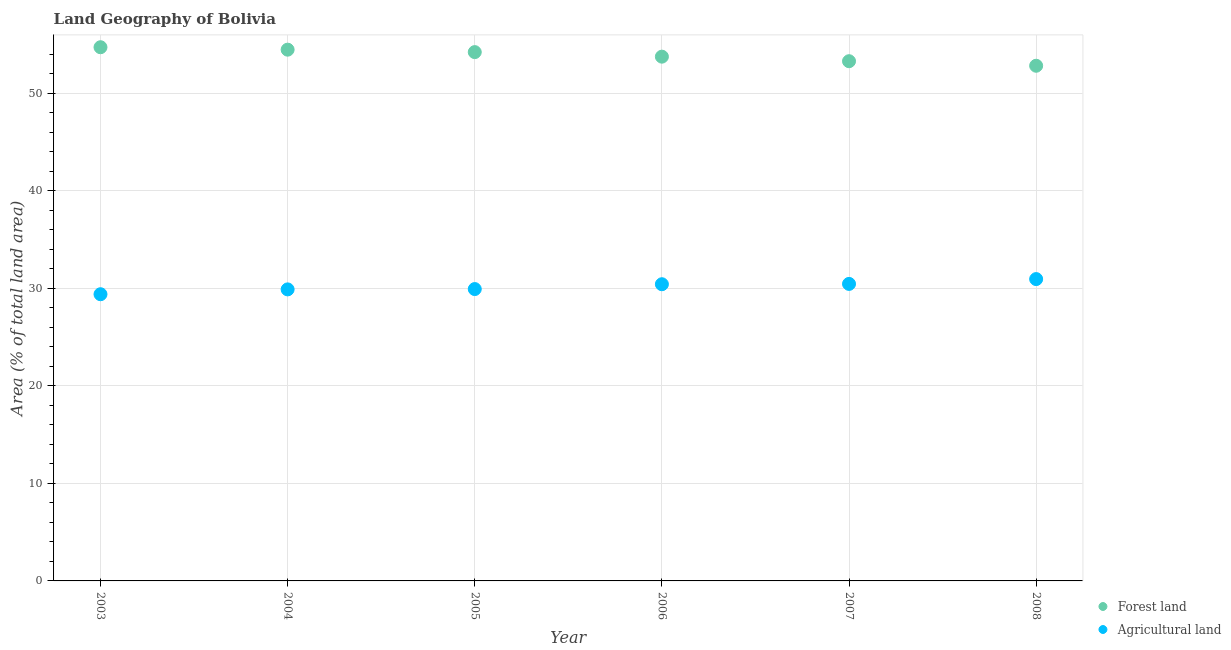What is the percentage of land area under agriculture in 2003?
Keep it short and to the point. 29.39. Across all years, what is the maximum percentage of land area under agriculture?
Your response must be concise. 30.95. Across all years, what is the minimum percentage of land area under agriculture?
Provide a succinct answer. 29.39. What is the total percentage of land area under agriculture in the graph?
Provide a short and direct response. 181.03. What is the difference between the percentage of land area under agriculture in 2003 and that in 2005?
Your answer should be very brief. -0.53. What is the difference between the percentage of land area under agriculture in 2007 and the percentage of land area under forests in 2006?
Provide a succinct answer. -23.3. What is the average percentage of land area under agriculture per year?
Offer a very short reply. 30.17. In the year 2007, what is the difference between the percentage of land area under agriculture and percentage of land area under forests?
Ensure brevity in your answer.  -22.83. What is the ratio of the percentage of land area under agriculture in 2005 to that in 2006?
Offer a terse response. 0.98. Is the difference between the percentage of land area under forests in 2004 and 2008 greater than the difference between the percentage of land area under agriculture in 2004 and 2008?
Your answer should be compact. Yes. What is the difference between the highest and the second highest percentage of land area under agriculture?
Keep it short and to the point. 0.49. What is the difference between the highest and the lowest percentage of land area under forests?
Offer a very short reply. 1.9. Is the sum of the percentage of land area under forests in 2003 and 2004 greater than the maximum percentage of land area under agriculture across all years?
Keep it short and to the point. Yes. Is the percentage of land area under agriculture strictly less than the percentage of land area under forests over the years?
Provide a short and direct response. Yes. How many dotlines are there?
Provide a succinct answer. 2. How many years are there in the graph?
Your answer should be very brief. 6. Does the graph contain grids?
Give a very brief answer. Yes. What is the title of the graph?
Ensure brevity in your answer.  Land Geography of Bolivia. What is the label or title of the Y-axis?
Your answer should be very brief. Area (% of total land area). What is the Area (% of total land area) in Forest land in 2003?
Provide a short and direct response. 54.72. What is the Area (% of total land area) of Agricultural land in 2003?
Keep it short and to the point. 29.39. What is the Area (% of total land area) in Forest land in 2004?
Your answer should be very brief. 54.47. What is the Area (% of total land area) of Agricultural land in 2004?
Make the answer very short. 29.89. What is the Area (% of total land area) in Forest land in 2005?
Your answer should be very brief. 54.22. What is the Area (% of total land area) in Agricultural land in 2005?
Provide a succinct answer. 29.92. What is the Area (% of total land area) of Forest land in 2006?
Provide a succinct answer. 53.75. What is the Area (% of total land area) in Agricultural land in 2006?
Give a very brief answer. 30.42. What is the Area (% of total land area) in Forest land in 2007?
Provide a short and direct response. 53.29. What is the Area (% of total land area) in Agricultural land in 2007?
Offer a very short reply. 30.45. What is the Area (% of total land area) in Forest land in 2008?
Make the answer very short. 52.82. What is the Area (% of total land area) of Agricultural land in 2008?
Your response must be concise. 30.95. Across all years, what is the maximum Area (% of total land area) of Forest land?
Your response must be concise. 54.72. Across all years, what is the maximum Area (% of total land area) in Agricultural land?
Make the answer very short. 30.95. Across all years, what is the minimum Area (% of total land area) of Forest land?
Offer a very short reply. 52.82. Across all years, what is the minimum Area (% of total land area) of Agricultural land?
Make the answer very short. 29.39. What is the total Area (% of total land area) in Forest land in the graph?
Ensure brevity in your answer.  323.26. What is the total Area (% of total land area) of Agricultural land in the graph?
Keep it short and to the point. 181.03. What is the difference between the Area (% of total land area) in Forest land in 2003 and that in 2004?
Your answer should be very brief. 0.25. What is the difference between the Area (% of total land area) in Agricultural land in 2003 and that in 2004?
Your answer should be compact. -0.5. What is the difference between the Area (% of total land area) in Forest land in 2003 and that in 2005?
Offer a very short reply. 0.5. What is the difference between the Area (% of total land area) in Agricultural land in 2003 and that in 2005?
Keep it short and to the point. -0.53. What is the difference between the Area (% of total land area) in Forest land in 2003 and that in 2006?
Your answer should be very brief. 0.97. What is the difference between the Area (% of total land area) in Agricultural land in 2003 and that in 2006?
Offer a terse response. -1.02. What is the difference between the Area (% of total land area) of Forest land in 2003 and that in 2007?
Provide a succinct answer. 1.43. What is the difference between the Area (% of total land area) in Agricultural land in 2003 and that in 2007?
Provide a short and direct response. -1.06. What is the difference between the Area (% of total land area) in Forest land in 2003 and that in 2008?
Provide a succinct answer. 1.9. What is the difference between the Area (% of total land area) in Agricultural land in 2003 and that in 2008?
Make the answer very short. -1.55. What is the difference between the Area (% of total land area) of Forest land in 2004 and that in 2005?
Ensure brevity in your answer.  0.25. What is the difference between the Area (% of total land area) of Agricultural land in 2004 and that in 2005?
Keep it short and to the point. -0.03. What is the difference between the Area (% of total land area) of Forest land in 2004 and that in 2006?
Offer a very short reply. 0.72. What is the difference between the Area (% of total land area) of Agricultural land in 2004 and that in 2006?
Provide a succinct answer. -0.53. What is the difference between the Area (% of total land area) in Forest land in 2004 and that in 2007?
Your response must be concise. 1.18. What is the difference between the Area (% of total land area) of Agricultural land in 2004 and that in 2007?
Offer a terse response. -0.56. What is the difference between the Area (% of total land area) in Forest land in 2004 and that in 2008?
Your answer should be compact. 1.65. What is the difference between the Area (% of total land area) in Agricultural land in 2004 and that in 2008?
Keep it short and to the point. -1.06. What is the difference between the Area (% of total land area) in Forest land in 2005 and that in 2006?
Give a very brief answer. 0.47. What is the difference between the Area (% of total land area) in Agricultural land in 2005 and that in 2006?
Ensure brevity in your answer.  -0.5. What is the difference between the Area (% of total land area) in Forest land in 2005 and that in 2007?
Offer a terse response. 0.93. What is the difference between the Area (% of total land area) of Agricultural land in 2005 and that in 2007?
Provide a succinct answer. -0.53. What is the difference between the Area (% of total land area) of Forest land in 2005 and that in 2008?
Offer a terse response. 1.4. What is the difference between the Area (% of total land area) in Agricultural land in 2005 and that in 2008?
Your answer should be compact. -1.02. What is the difference between the Area (% of total land area) of Forest land in 2006 and that in 2007?
Give a very brief answer. 0.47. What is the difference between the Area (% of total land area) of Agricultural land in 2006 and that in 2007?
Make the answer very short. -0.03. What is the difference between the Area (% of total land area) of Forest land in 2006 and that in 2008?
Make the answer very short. 0.93. What is the difference between the Area (% of total land area) in Agricultural land in 2006 and that in 2008?
Offer a terse response. -0.53. What is the difference between the Area (% of total land area) of Forest land in 2007 and that in 2008?
Offer a terse response. 0.47. What is the difference between the Area (% of total land area) of Agricultural land in 2007 and that in 2008?
Offer a very short reply. -0.49. What is the difference between the Area (% of total land area) in Forest land in 2003 and the Area (% of total land area) in Agricultural land in 2004?
Provide a short and direct response. 24.83. What is the difference between the Area (% of total land area) in Forest land in 2003 and the Area (% of total land area) in Agricultural land in 2005?
Offer a very short reply. 24.8. What is the difference between the Area (% of total land area) of Forest land in 2003 and the Area (% of total land area) of Agricultural land in 2006?
Give a very brief answer. 24.3. What is the difference between the Area (% of total land area) in Forest land in 2003 and the Area (% of total land area) in Agricultural land in 2007?
Provide a short and direct response. 24.27. What is the difference between the Area (% of total land area) in Forest land in 2003 and the Area (% of total land area) in Agricultural land in 2008?
Give a very brief answer. 23.77. What is the difference between the Area (% of total land area) of Forest land in 2004 and the Area (% of total land area) of Agricultural land in 2005?
Offer a terse response. 24.54. What is the difference between the Area (% of total land area) of Forest land in 2004 and the Area (% of total land area) of Agricultural land in 2006?
Provide a succinct answer. 24.05. What is the difference between the Area (% of total land area) of Forest land in 2004 and the Area (% of total land area) of Agricultural land in 2007?
Your answer should be compact. 24.02. What is the difference between the Area (% of total land area) of Forest land in 2004 and the Area (% of total land area) of Agricultural land in 2008?
Provide a short and direct response. 23.52. What is the difference between the Area (% of total land area) of Forest land in 2005 and the Area (% of total land area) of Agricultural land in 2006?
Your answer should be very brief. 23.8. What is the difference between the Area (% of total land area) in Forest land in 2005 and the Area (% of total land area) in Agricultural land in 2007?
Keep it short and to the point. 23.77. What is the difference between the Area (% of total land area) of Forest land in 2005 and the Area (% of total land area) of Agricultural land in 2008?
Give a very brief answer. 23.27. What is the difference between the Area (% of total land area) of Forest land in 2006 and the Area (% of total land area) of Agricultural land in 2007?
Your response must be concise. 23.3. What is the difference between the Area (% of total land area) of Forest land in 2006 and the Area (% of total land area) of Agricultural land in 2008?
Give a very brief answer. 22.8. What is the difference between the Area (% of total land area) of Forest land in 2007 and the Area (% of total land area) of Agricultural land in 2008?
Your answer should be compact. 22.34. What is the average Area (% of total land area) of Forest land per year?
Offer a terse response. 53.88. What is the average Area (% of total land area) in Agricultural land per year?
Ensure brevity in your answer.  30.17. In the year 2003, what is the difference between the Area (% of total land area) in Forest land and Area (% of total land area) in Agricultural land?
Make the answer very short. 25.32. In the year 2004, what is the difference between the Area (% of total land area) in Forest land and Area (% of total land area) in Agricultural land?
Your answer should be compact. 24.58. In the year 2005, what is the difference between the Area (% of total land area) of Forest land and Area (% of total land area) of Agricultural land?
Offer a very short reply. 24.29. In the year 2006, what is the difference between the Area (% of total land area) of Forest land and Area (% of total land area) of Agricultural land?
Your answer should be compact. 23.33. In the year 2007, what is the difference between the Area (% of total land area) in Forest land and Area (% of total land area) in Agricultural land?
Your answer should be compact. 22.83. In the year 2008, what is the difference between the Area (% of total land area) of Forest land and Area (% of total land area) of Agricultural land?
Your response must be concise. 21.87. What is the ratio of the Area (% of total land area) in Forest land in 2003 to that in 2004?
Provide a succinct answer. 1. What is the ratio of the Area (% of total land area) in Agricultural land in 2003 to that in 2004?
Give a very brief answer. 0.98. What is the ratio of the Area (% of total land area) of Forest land in 2003 to that in 2005?
Ensure brevity in your answer.  1.01. What is the ratio of the Area (% of total land area) in Agricultural land in 2003 to that in 2005?
Provide a short and direct response. 0.98. What is the ratio of the Area (% of total land area) in Agricultural land in 2003 to that in 2006?
Ensure brevity in your answer.  0.97. What is the ratio of the Area (% of total land area) in Forest land in 2003 to that in 2007?
Offer a very short reply. 1.03. What is the ratio of the Area (% of total land area) of Agricultural land in 2003 to that in 2007?
Your response must be concise. 0.97. What is the ratio of the Area (% of total land area) in Forest land in 2003 to that in 2008?
Make the answer very short. 1.04. What is the ratio of the Area (% of total land area) in Agricultural land in 2003 to that in 2008?
Provide a short and direct response. 0.95. What is the ratio of the Area (% of total land area) in Agricultural land in 2004 to that in 2005?
Keep it short and to the point. 1. What is the ratio of the Area (% of total land area) in Forest land in 2004 to that in 2006?
Make the answer very short. 1.01. What is the ratio of the Area (% of total land area) in Agricultural land in 2004 to that in 2006?
Your answer should be very brief. 0.98. What is the ratio of the Area (% of total land area) of Forest land in 2004 to that in 2007?
Your answer should be very brief. 1.02. What is the ratio of the Area (% of total land area) of Agricultural land in 2004 to that in 2007?
Your answer should be compact. 0.98. What is the ratio of the Area (% of total land area) in Forest land in 2004 to that in 2008?
Your response must be concise. 1.03. What is the ratio of the Area (% of total land area) in Agricultural land in 2004 to that in 2008?
Provide a short and direct response. 0.97. What is the ratio of the Area (% of total land area) of Forest land in 2005 to that in 2006?
Keep it short and to the point. 1.01. What is the ratio of the Area (% of total land area) in Agricultural land in 2005 to that in 2006?
Provide a succinct answer. 0.98. What is the ratio of the Area (% of total land area) of Forest land in 2005 to that in 2007?
Your response must be concise. 1.02. What is the ratio of the Area (% of total land area) in Agricultural land in 2005 to that in 2007?
Your answer should be very brief. 0.98. What is the ratio of the Area (% of total land area) in Forest land in 2005 to that in 2008?
Offer a very short reply. 1.03. What is the ratio of the Area (% of total land area) of Agricultural land in 2005 to that in 2008?
Make the answer very short. 0.97. What is the ratio of the Area (% of total land area) of Forest land in 2006 to that in 2007?
Your answer should be compact. 1.01. What is the ratio of the Area (% of total land area) in Forest land in 2006 to that in 2008?
Give a very brief answer. 1.02. What is the ratio of the Area (% of total land area) of Agricultural land in 2006 to that in 2008?
Give a very brief answer. 0.98. What is the ratio of the Area (% of total land area) of Forest land in 2007 to that in 2008?
Provide a short and direct response. 1.01. What is the ratio of the Area (% of total land area) in Agricultural land in 2007 to that in 2008?
Your answer should be compact. 0.98. What is the difference between the highest and the second highest Area (% of total land area) in Forest land?
Your answer should be very brief. 0.25. What is the difference between the highest and the second highest Area (% of total land area) of Agricultural land?
Your response must be concise. 0.49. What is the difference between the highest and the lowest Area (% of total land area) in Forest land?
Your answer should be compact. 1.9. What is the difference between the highest and the lowest Area (% of total land area) of Agricultural land?
Provide a short and direct response. 1.55. 